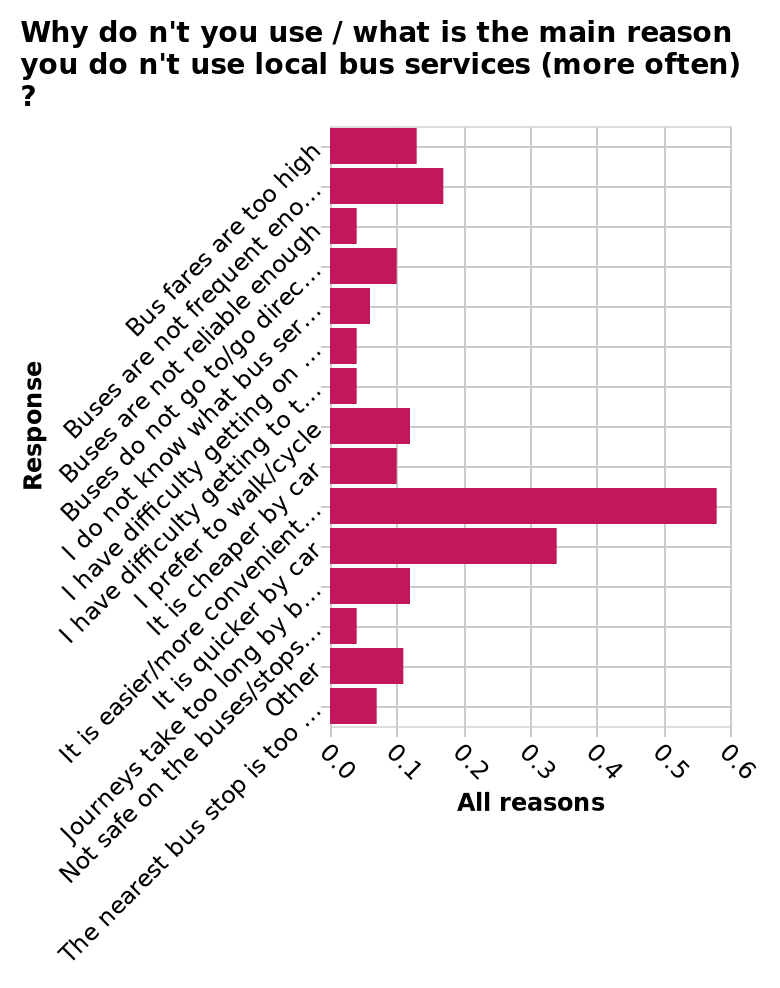<image>
In terms of speed, how does using a car compare to other forms of transportation? It's quicker to use a car. Why do people prefer using a car instead of other means of transportation?  The most given reason is that it is easier and more convenient. What are the top reasons for people opting to use a car?  The most given reason is that it is easier and more convenient, followed closely by it's quicker to use a car. What does the bar diagram illustrate?  The bar diagram illustrates the main reasons or factors influencing the infrequent use of local bus services. 